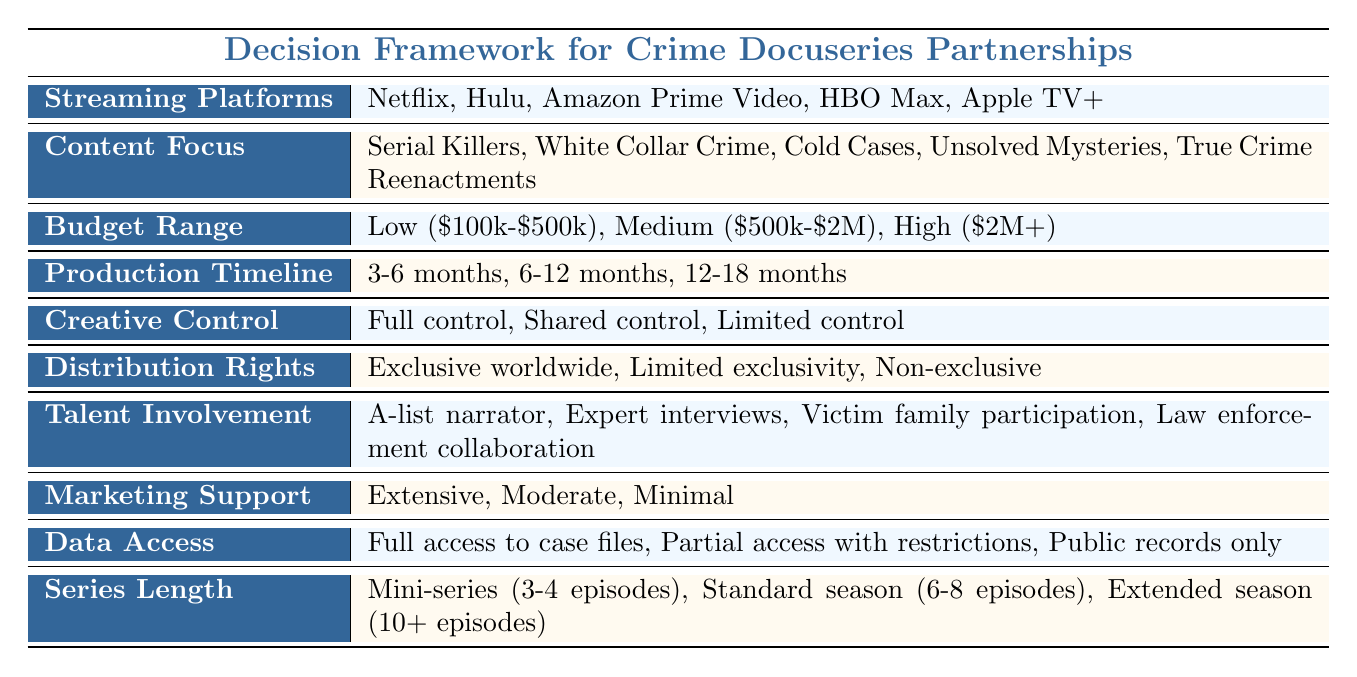What are the streaming platforms listed in the table? The table directly lists five streaming platforms under the "Streaming Platforms" category: Netflix, Hulu, Amazon Prime Video, HBO Max, and Apple TV+.
Answer: Netflix, Hulu, Amazon Prime Video, HBO Max, Apple TV+ Which content focus is specifically mentioned for HBO Max? The table does not specify content focus for individual streaming platforms; it lists several content focus options applicable to all platforms. Therefore, HBO Max does not have a specific focus mentioned in the table itself.
Answer: Not specified How many months is the minimum production timeline stated in the table? The table lists three options for production timelines. The shortest option is 3-6 months, so the minimum production timeline is 3 months.
Answer: 3 months Is there a streaming platform that offers unlimited exclusivity for distribution rights? The table lists distribution rights options but mentions no platform that specifically offers exclusive worldwide rights. Hence, no such mention exists.
Answer: No Which talent involvement option involves direct participation from families of victims? The table lists various talent involvement options, including "Victim family participation." This option directly indicates family involvement in the project.
Answer: Victim family participation What is the total number of content focus areas available for partnership? The table lists five specific content focus areas: Serial Killers, White Collar Crime, Cold Cases, Unsolved Mysteries, and True Crime Reenactments. Therefore, the count is five.
Answer: 5 Which streaming platform requires a medium budget range for productions? The table lists different budget ranges without assigning them to specific platforms. Therefore, there's no indication of which platform requires a medium budget range directly in the table.
Answer: Not specified If you wanted to create a mini-series, what is the maximum number of episodes allowed? The table states that a mini-series consists of 3-4 episodes. Thus, the maximum number of episodes for a mini-series is 4.
Answer: 4 episodes What type of access to data is offered on public records only? The table indicates that "Public records only" is one of the options for data access, meaning any structured docuseries could be limited to this.
Answer: Public records only 